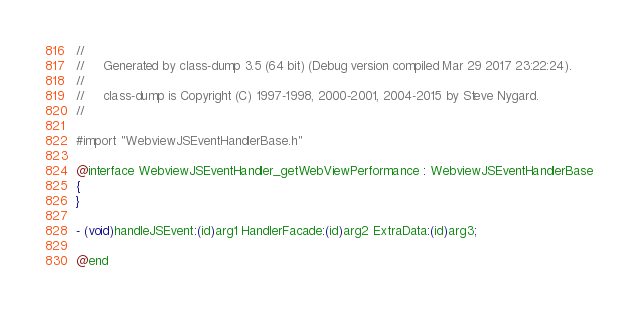<code> <loc_0><loc_0><loc_500><loc_500><_C_>//
//     Generated by class-dump 3.5 (64 bit) (Debug version compiled Mar 29 2017 23:22:24).
//
//     class-dump is Copyright (C) 1997-1998, 2000-2001, 2004-2015 by Steve Nygard.
//

#import "WebviewJSEventHandlerBase.h"

@interface WebviewJSEventHandler_getWebViewPerformance : WebviewJSEventHandlerBase
{
}

- (void)handleJSEvent:(id)arg1 HandlerFacade:(id)arg2 ExtraData:(id)arg3;

@end

</code> 